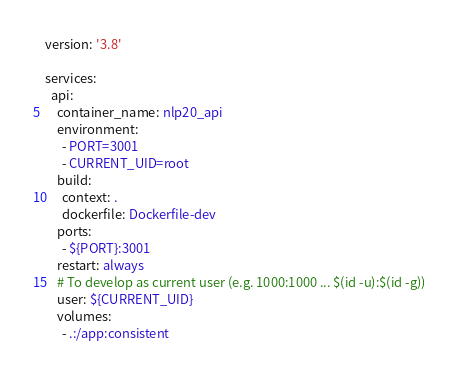<code> <loc_0><loc_0><loc_500><loc_500><_YAML_>version: '3.8'

services:
  api:
    container_name: nlp20_api
    environment:
      - PORT=3001
      - CURRENT_UID=root
    build:
      context: .
      dockerfile: Dockerfile-dev
    ports:
      - ${PORT}:3001
    restart: always
    # To develop as current user (e.g. 1000:1000 ... $(id -u):$(id -g))
    user: ${CURRENT_UID}
    volumes:
      - .:/app:consistent
</code> 